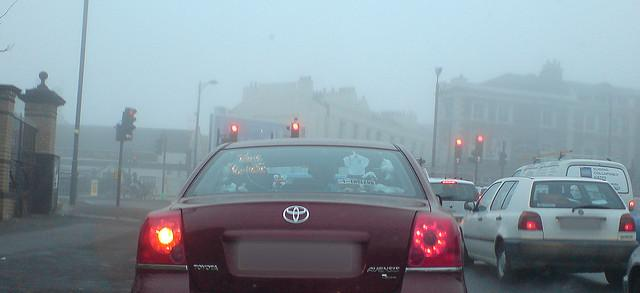Why are the license plates invisible? blurred 